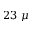<formula> <loc_0><loc_0><loc_500><loc_500>2 3 \mu</formula> 